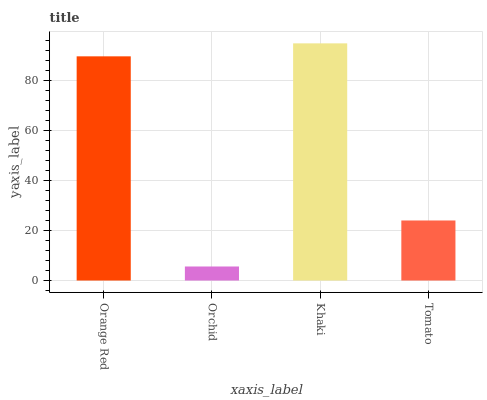Is Khaki the minimum?
Answer yes or no. No. Is Orchid the maximum?
Answer yes or no. No. Is Khaki greater than Orchid?
Answer yes or no. Yes. Is Orchid less than Khaki?
Answer yes or no. Yes. Is Orchid greater than Khaki?
Answer yes or no. No. Is Khaki less than Orchid?
Answer yes or no. No. Is Orange Red the high median?
Answer yes or no. Yes. Is Tomato the low median?
Answer yes or no. Yes. Is Tomato the high median?
Answer yes or no. No. Is Orange Red the low median?
Answer yes or no. No. 